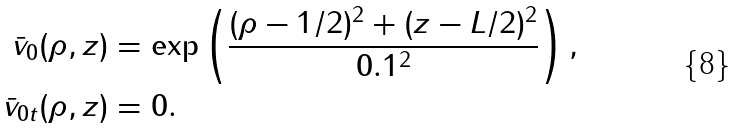<formula> <loc_0><loc_0><loc_500><loc_500>\bar { v } _ { 0 } ( \rho , z ) & = \exp \left ( \frac { ( \rho - 1 / 2 ) ^ { 2 } + ( z - L / 2 ) ^ { 2 } } { 0 . 1 ^ { 2 } } \right ) , \\ \bar { v } _ { 0 t } ( \rho , z ) & = 0 .</formula> 